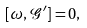Convert formula to latex. <formula><loc_0><loc_0><loc_500><loc_500>[ \omega , \mathcal { G } ^ { \prime } ] = 0 ,</formula> 